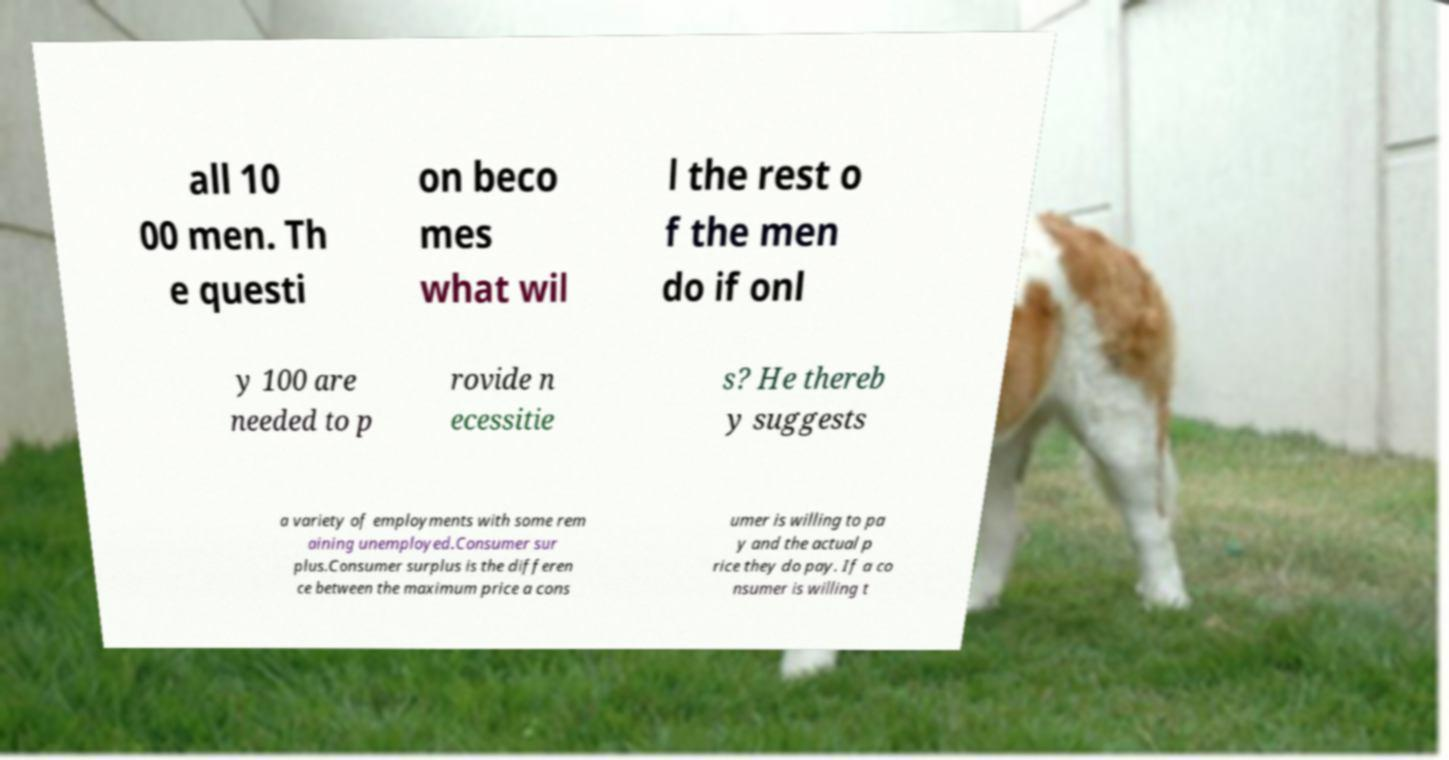Could you assist in decoding the text presented in this image and type it out clearly? all 10 00 men. Th e questi on beco mes what wil l the rest o f the men do if onl y 100 are needed to p rovide n ecessitie s? He thereb y suggests a variety of employments with some rem aining unemployed.Consumer sur plus.Consumer surplus is the differen ce between the maximum price a cons umer is willing to pa y and the actual p rice they do pay. If a co nsumer is willing t 